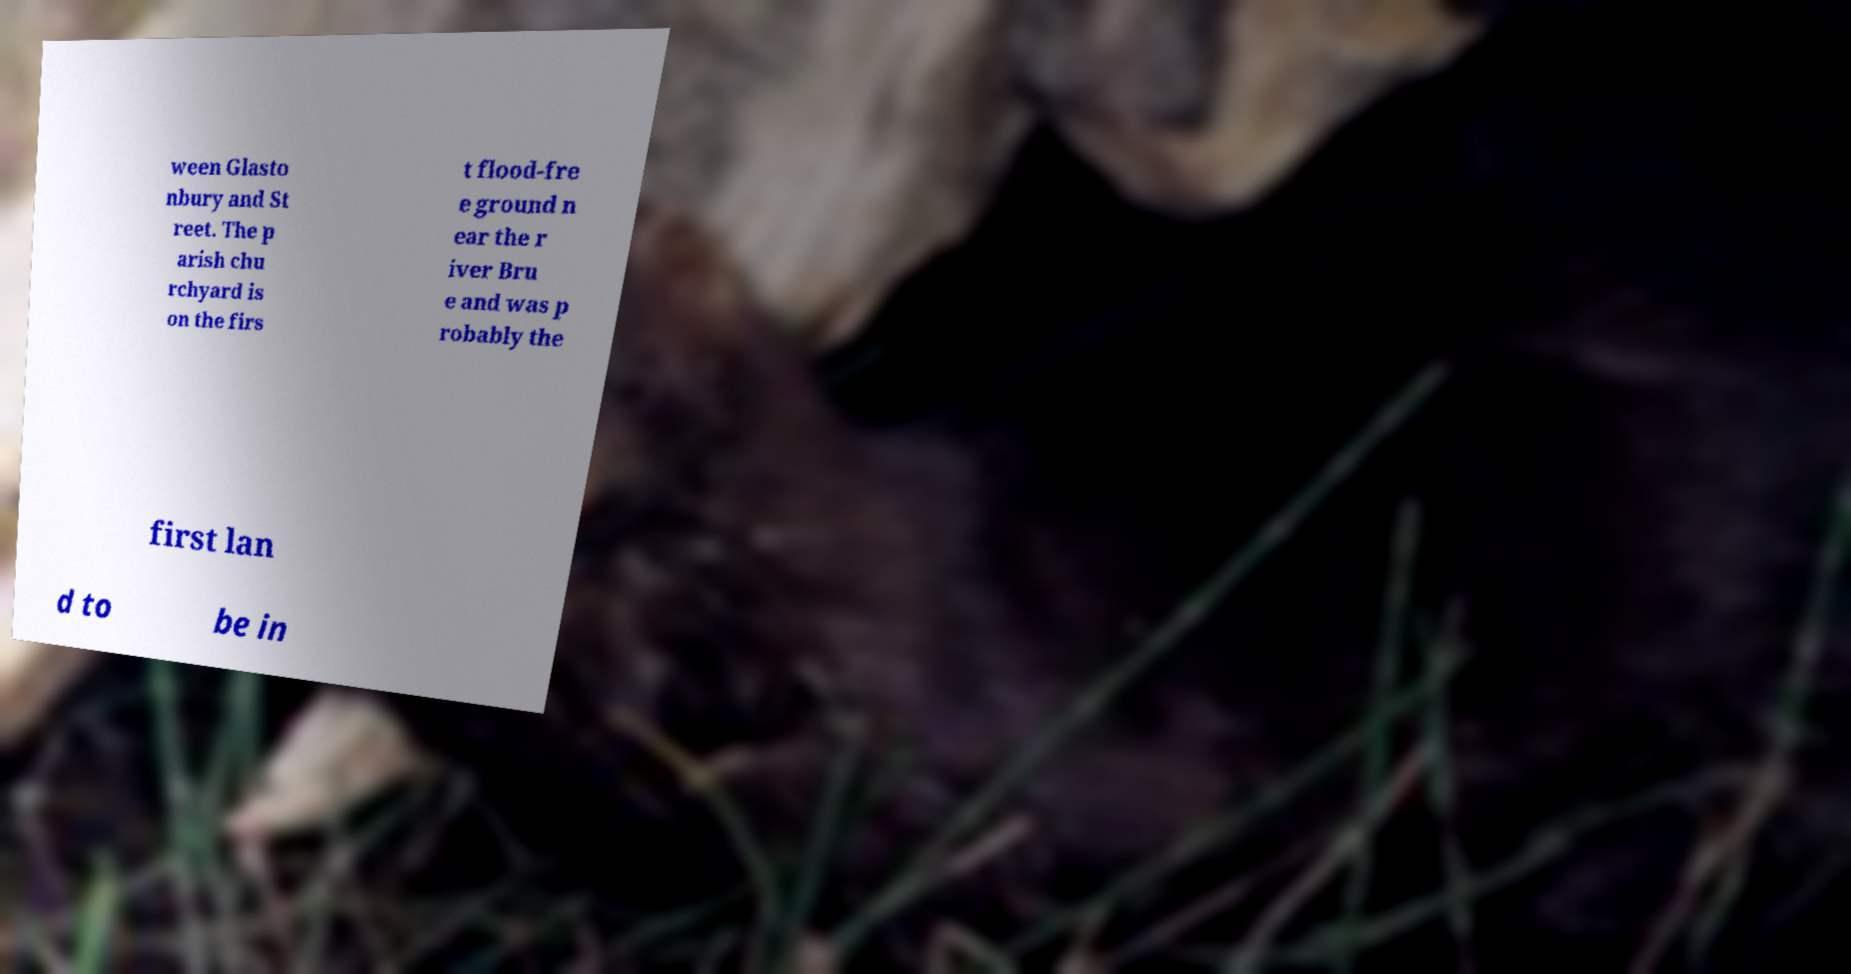I need the written content from this picture converted into text. Can you do that? ween Glasto nbury and St reet. The p arish chu rchyard is on the firs t flood-fre e ground n ear the r iver Bru e and was p robably the first lan d to be in 